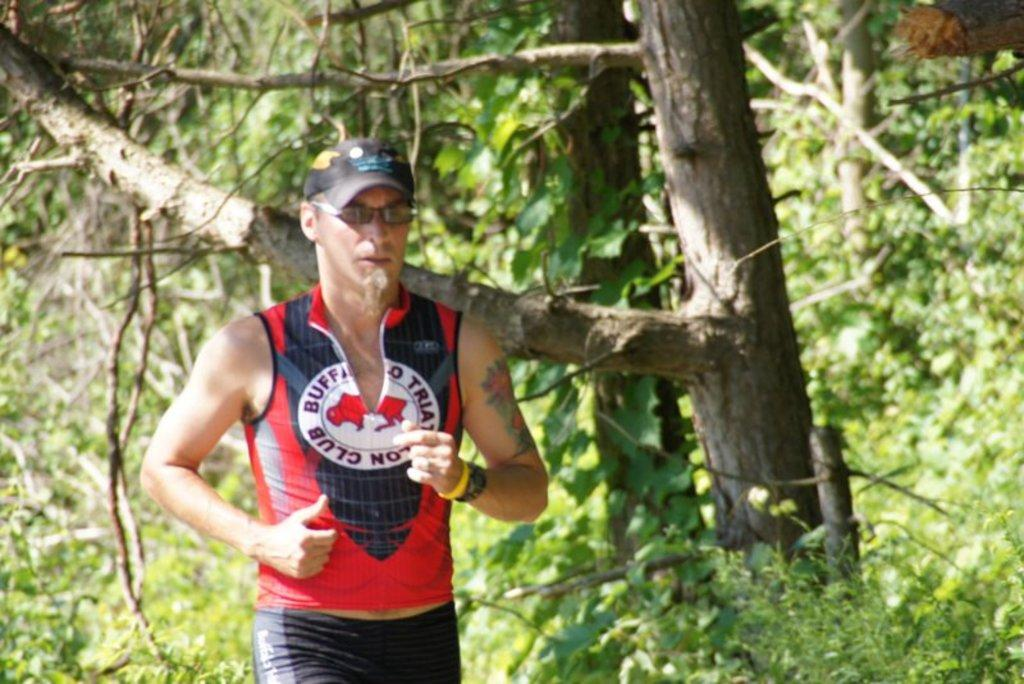What is the main subject of the image? The main subject of the image is a man. What is the man doing in the image? The man is jogging in the image. What accessories is the man wearing in the image? The man is wearing a cap and glasses in the image. What can be seen in the background of the image? There are trees in the background of the image. How many eggs are visible in the image? There are no eggs present in the image. What type of voyage is the man embarking on in the image? The image does not depict a voyage, as the man is simply jogging. 